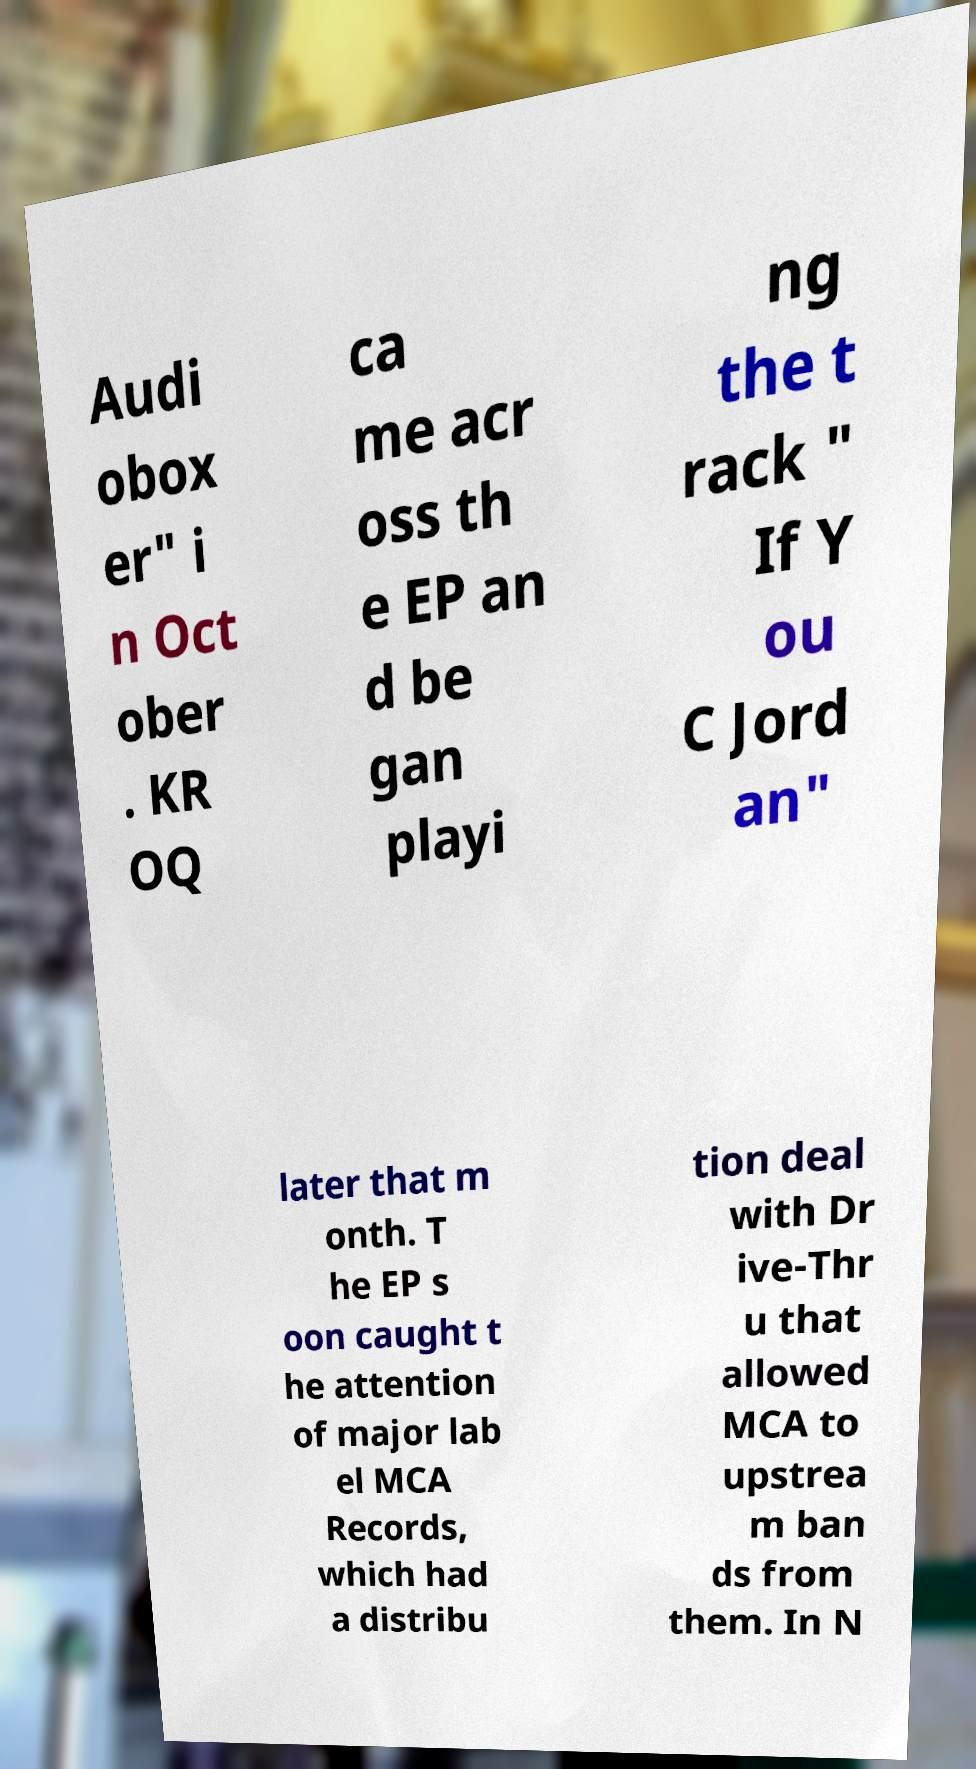Please identify and transcribe the text found in this image. Audi obox er" i n Oct ober . KR OQ ca me acr oss th e EP an d be gan playi ng the t rack " If Y ou C Jord an" later that m onth. T he EP s oon caught t he attention of major lab el MCA Records, which had a distribu tion deal with Dr ive-Thr u that allowed MCA to upstrea m ban ds from them. In N 